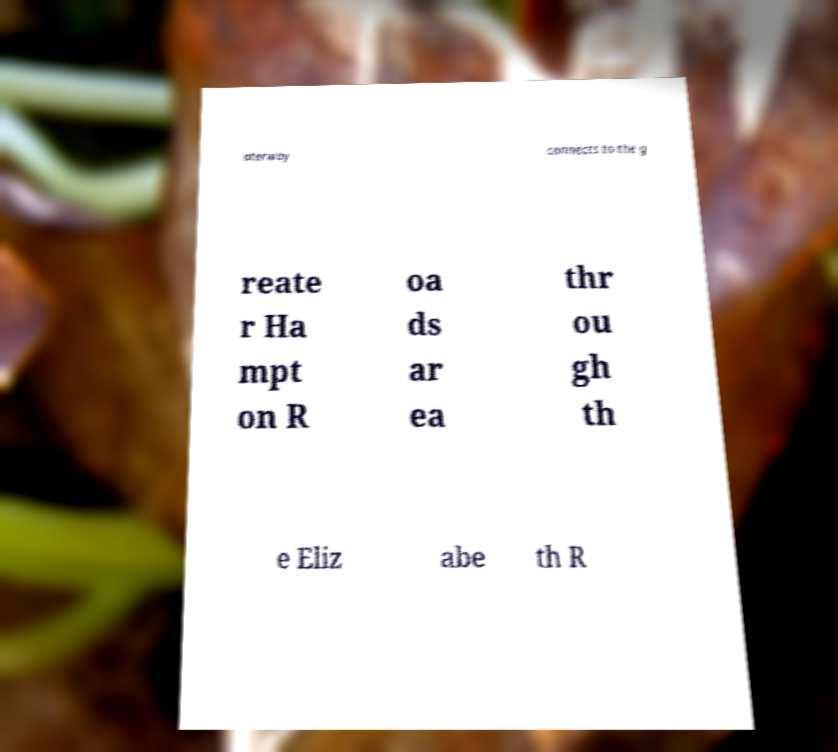I need the written content from this picture converted into text. Can you do that? aterway connects to the g reate r Ha mpt on R oa ds ar ea thr ou gh th e Eliz abe th R 